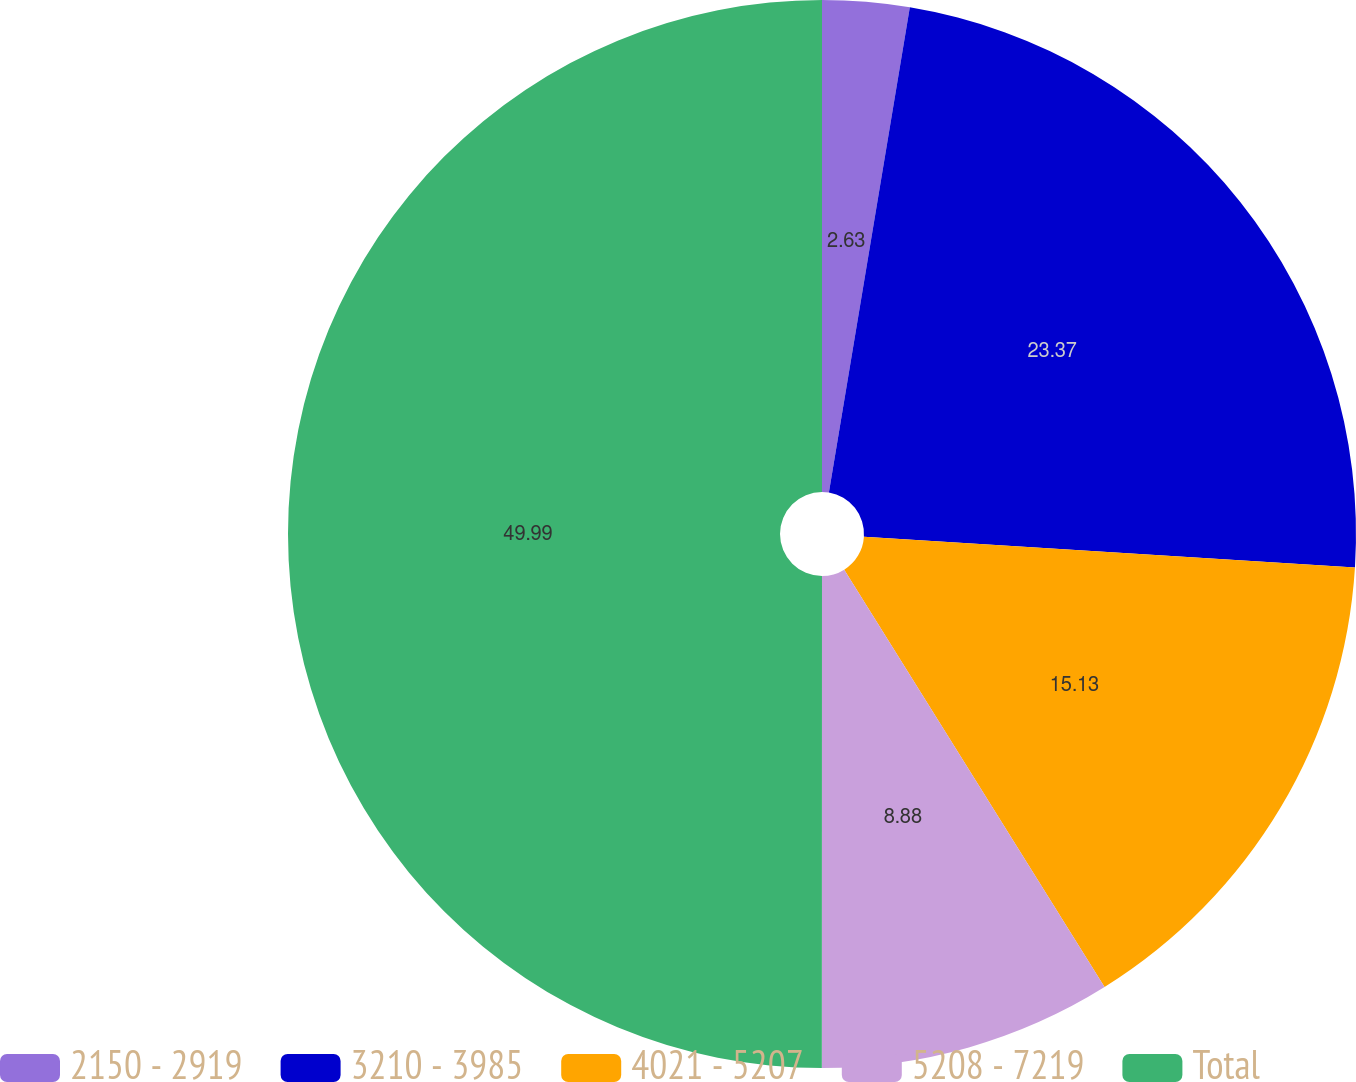<chart> <loc_0><loc_0><loc_500><loc_500><pie_chart><fcel>2150 - 2919<fcel>3210 - 3985<fcel>4021 - 5207<fcel>5208 - 7219<fcel>Total<nl><fcel>2.63%<fcel>23.37%<fcel>15.13%<fcel>8.88%<fcel>50.0%<nl></chart> 